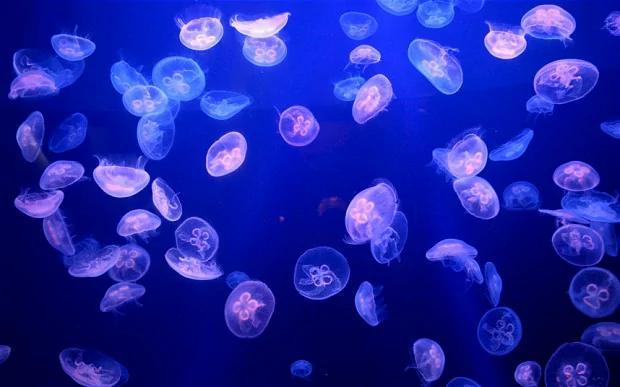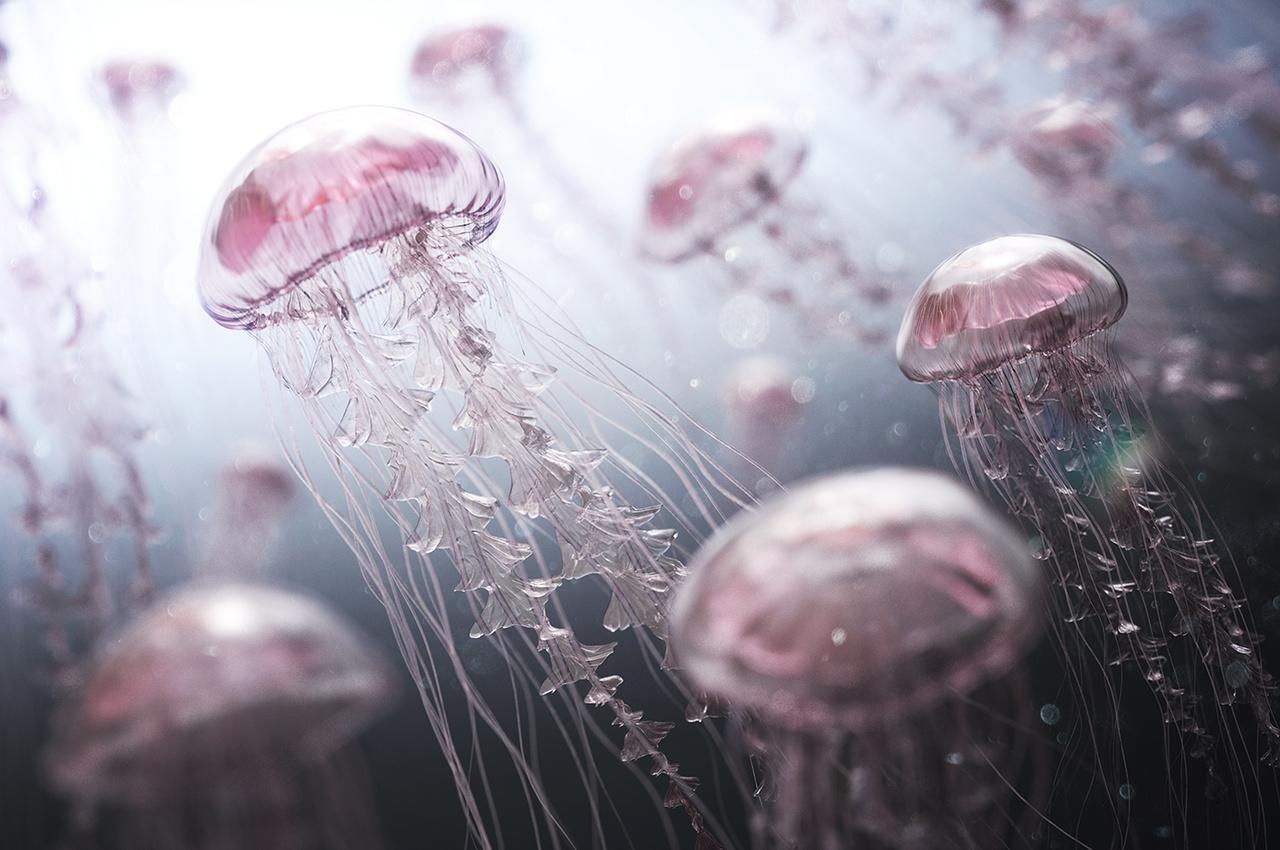The first image is the image on the left, the second image is the image on the right. Examine the images to the left and right. Is the description "The rippled surface of the water is visible in one of the images." accurate? Answer yes or no. No. 